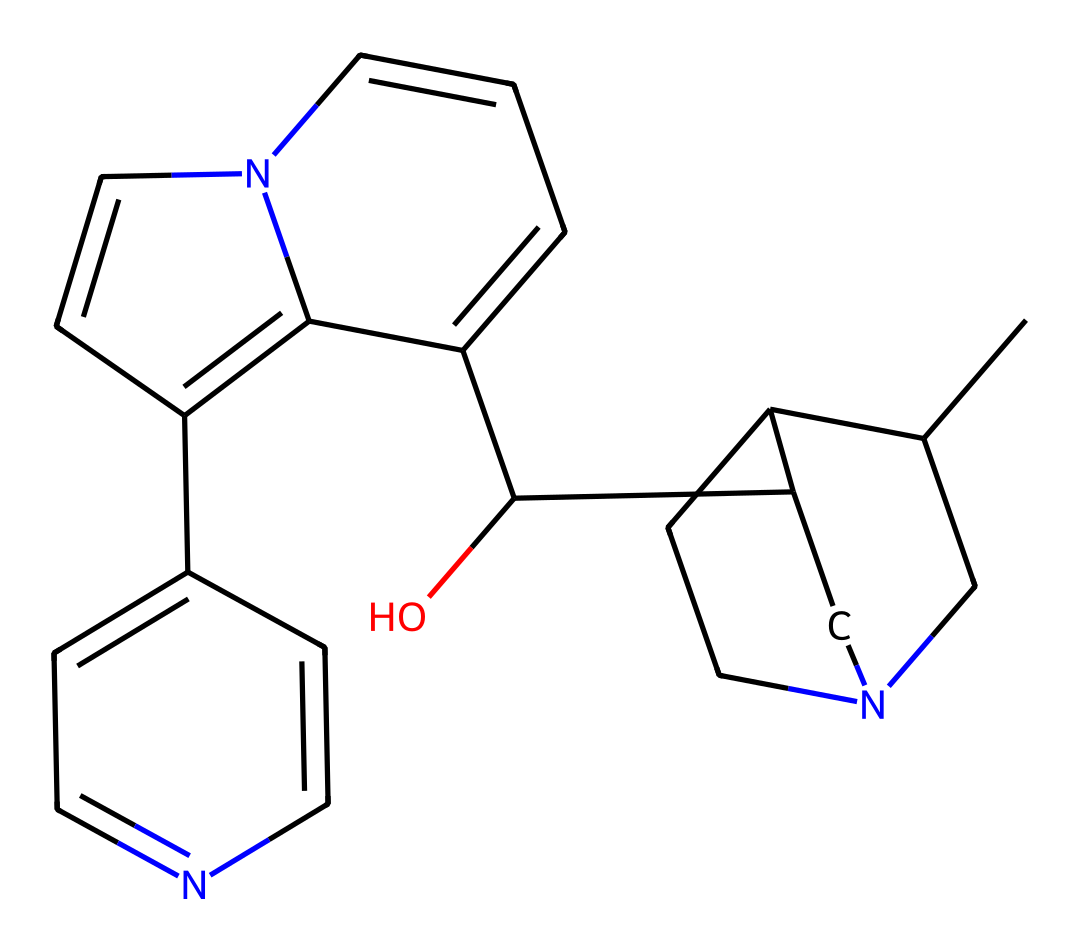What is the molecular formula of quinine? To find the molecular formula, we count the number of each type of atom present in the SMILES representation. The structure consists of 20 carbon atoms, 24 hydrogen atoms, 1 nitrogen atom and 1 oxygen atom. Thus, the molecular formula is C20H24N2O.
Answer: C20H24N2O How many nitrogen atoms are in quinine? By analyzing the SMILES representation, we can identify the number of nitrogen atoms present. There are two instances of 'N' in the structure, indicating that there are two nitrogen atoms in quinine.
Answer: 2 What type of chemical compound is quinine? Quinine is classified as an alkaloid, which are naturally occurring compounds primarily containing basic nitrogen atoms. Given the presence of nitrogen and its natural origin, it is categorized specifically as an alkaloid.
Answer: alkaloid Which element is responsible for the bitter taste of quinine? The presence of nitrogen is critical in defining the properties of alkaloids, including their taste. In quinine, the nitrogen atoms contribute to the compound's characteristic bitterness.
Answer: nitrogen What is the stereochemistry of quinine in terms of chiral centers? By examining the structure, we can identify chiral centers by locating carbon atoms bonded to four different substituents. Quinine has several chiral centers leading to a specific stereochemistry. There are 2 chiral centers present.
Answer: 2 How many rings are present in the structure of quinine? Looking at the SMILES structure, we can observe the presence of multiple cyclic components. By analyzing, we see that there are three distinct ring structures within the quinine molecule.
Answer: 3 